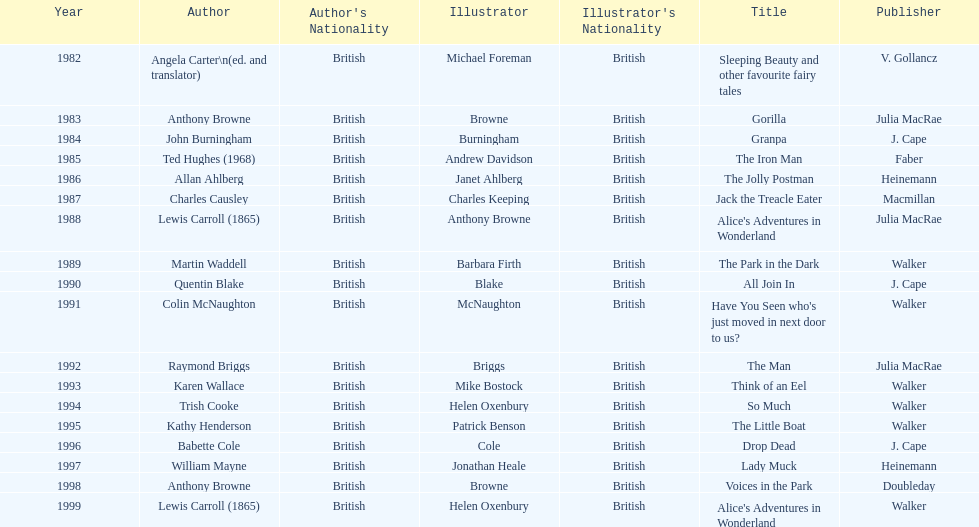What's the difference in years between angela carter's title and anthony browne's? 1. 